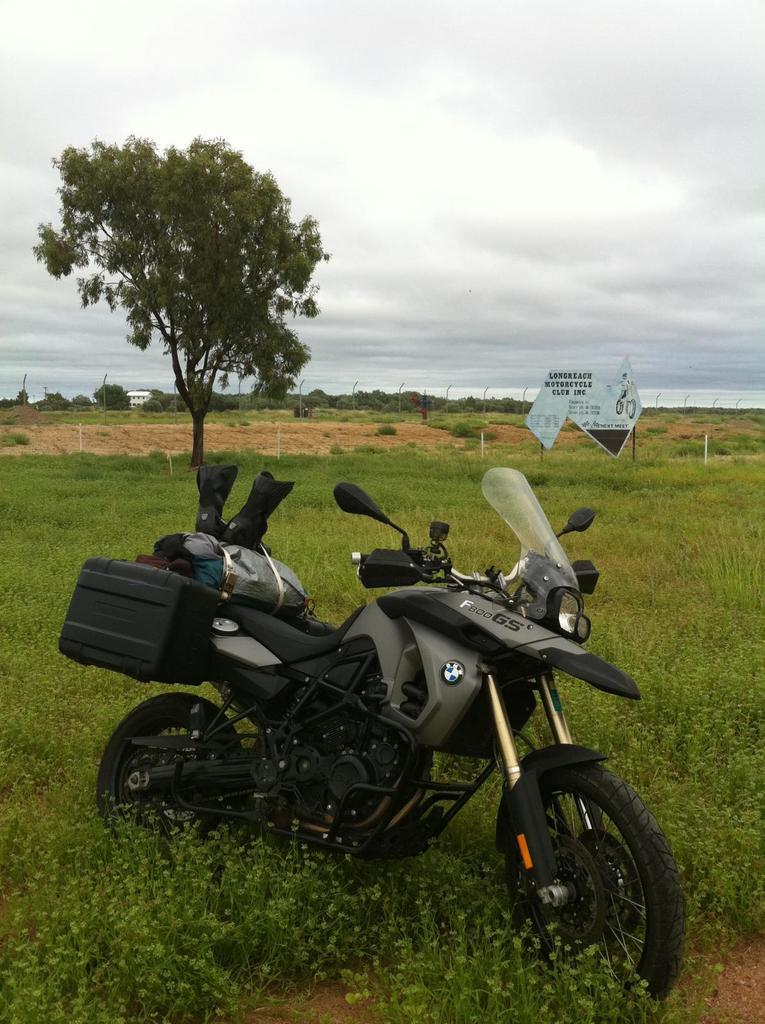What is the main object in the center of the image? There is a bike in the center of the image. What can be seen in the background of the image? There are trees and the sky visible in the background of the image. What type of surface is at the bottom of the image? There is grass at the bottom of the image. What else is present in the image besides the bike and grass? There is a board in the image. Can you see a gun being used by someone in the image? No, there is no gun or anyone using a gun in the image. Is there a cellar visible in the image? No, there is no cellar present in the image. 